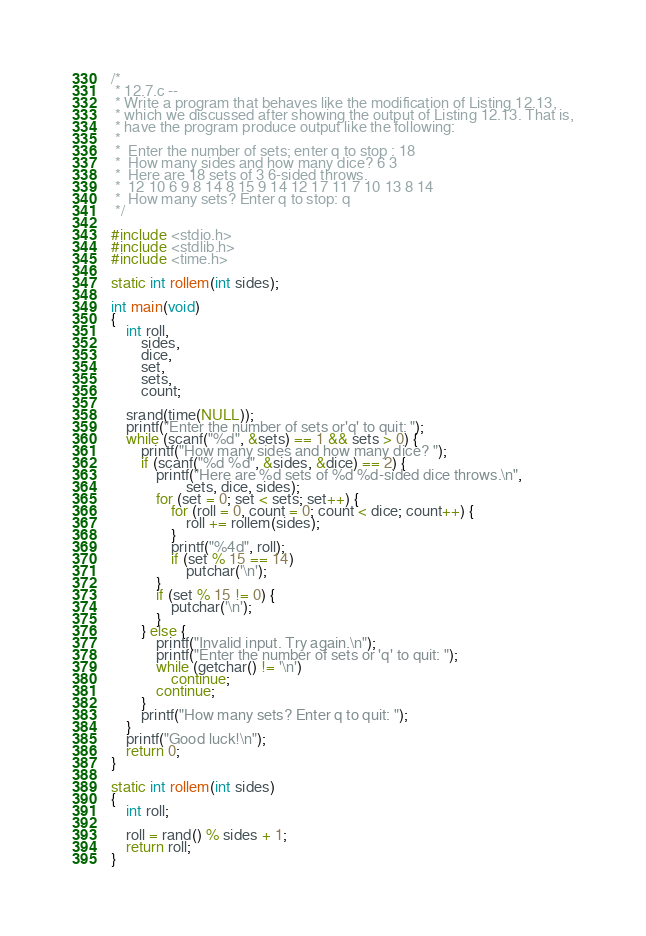Convert code to text. <code><loc_0><loc_0><loc_500><loc_500><_C_>/*
 * 12.7.c --
 * Write a program that behaves like the modification of Listing 12.13,
 * which we discussed after showing the output of Listing 12.13. That is,
 * have the program produce output like the following:
 *
 * 	Enter the number of sets; enter q to stop : 18
 * 	How many sides and how many dice? 6 3
 * 	Here are 18 sets of 3 6-sided throws.
 * 	12 10 6 9 8 14 8 15 9 14 12 17 11 7 10 13 8 14
 * 	How many sets? Enter q to stop: q
 */

#include <stdio.h>
#include <stdlib.h>
#include <time.h>

static int rollem(int sides);

int main(void)
{
	int roll,
		sides,
		dice,
		set,
		sets,
		count;

	srand(time(NULL));
	printf("Enter the number of sets or'q' to quit: ");
	while (scanf("%d", &sets) == 1 && sets > 0) {
		printf("How many sides and how many dice? ");
		if (scanf("%d %d", &sides, &dice) == 2) {
			printf("Here are %d sets of %d %d-sided dice throws.\n",
					sets, dice, sides);
			for (set = 0; set < sets; set++) {
				for (roll = 0, count = 0; count < dice; count++) {
					roll += rollem(sides);
				}
				printf("%4d", roll);
				if (set % 15 == 14)
					putchar('\n');
			}
			if (set % 15 != 0) {
				putchar('\n');
			}
		} else {
			printf("Invalid input. Try again.\n");
			printf("Enter the number of sets or 'q' to quit: ");
			while (getchar() != '\n')
				continue;
			continue;
		}
		printf("How many sets? Enter q to quit: ");
	}
	printf("Good luck!\n");
	return 0;
}

static int rollem(int sides)
{
	int roll;

	roll = rand() % sides + 1;
	return roll;
}
</code> 